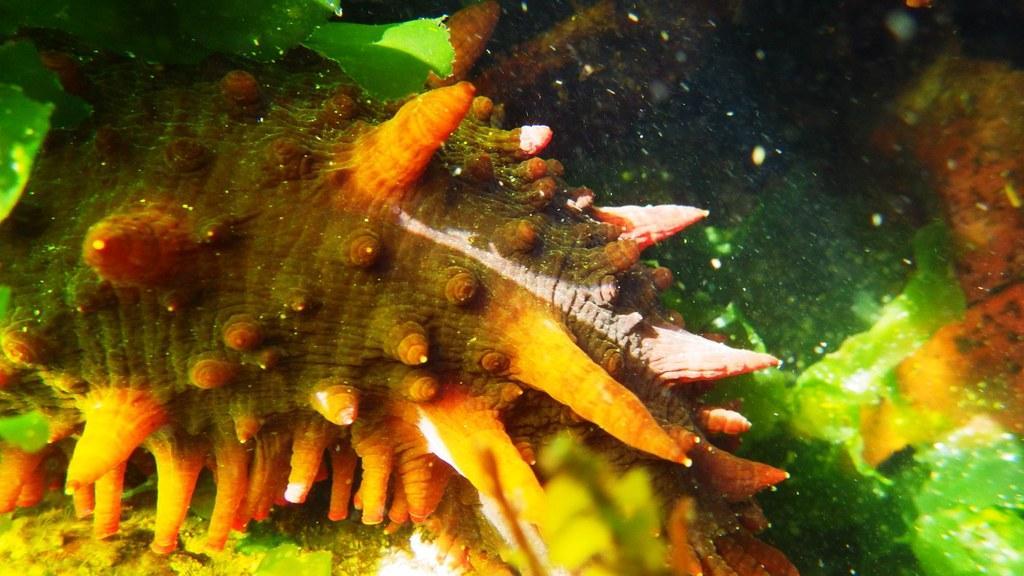Describe this image in one or two sentences. In this image we can see there is a water animal in the water and there is some algae. 